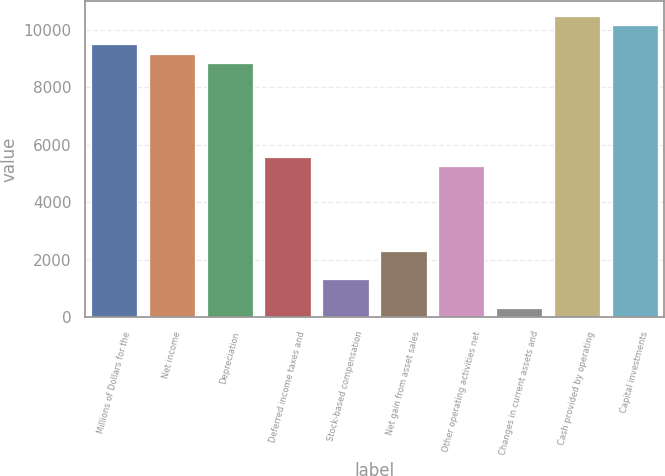Convert chart. <chart><loc_0><loc_0><loc_500><loc_500><bar_chart><fcel>Millions of Dollars for the<fcel>Net income<fcel>Depreciation<fcel>Deferred income taxes and<fcel>Stock-based compensation<fcel>Net gain from asset sales<fcel>Other operating activities net<fcel>Changes in current assets and<fcel>Cash provided by operating<fcel>Capital investments<nl><fcel>9497.6<fcel>9170.2<fcel>8842.8<fcel>5568.8<fcel>1312.6<fcel>2294.8<fcel>5241.4<fcel>330.4<fcel>10479.8<fcel>10152.4<nl></chart> 